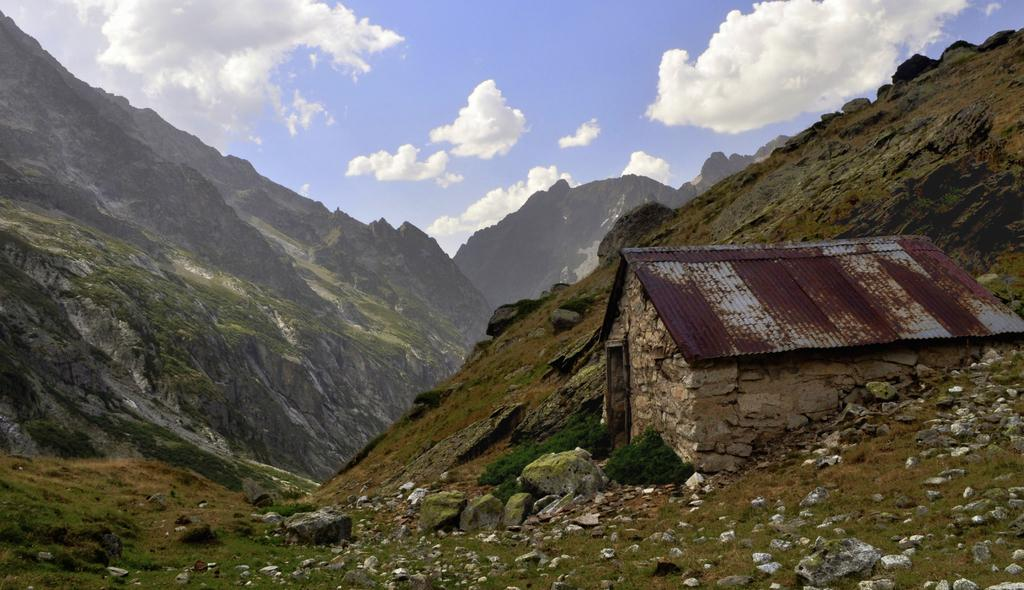What type of structure is located on the cliff in the foreground of the image? There is a hut on a cliff in the foreground of the image. What can be seen on the ground in the foreground of the image? Stones and grass are present in the foreground of the image. What is visible in the background of the image? There are mountains and the sky visible in the background of the image. What is present in the sky in the background of the image? Clouds are present in the sky in the background of the image. What type of pollution can be seen in the image? There is no indication of pollution in the image. Can you describe the throat of the person in the image? There is no person present in the image, so it is not possible to describe their throat. 